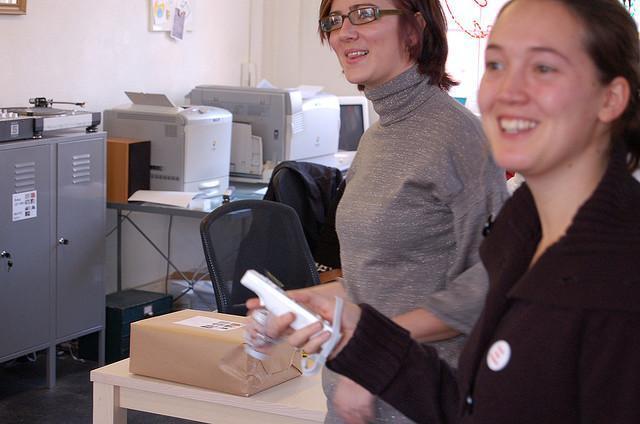How many people are visible?
Give a very brief answer. 2. How many knives to the left?
Give a very brief answer. 0. 